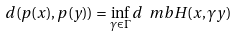Convert formula to latex. <formula><loc_0><loc_0><loc_500><loc_500>d ( p ( x ) , p ( y ) ) = \inf _ { \gamma \in \Gamma } d _ { \ } m b { H } ( x , \gamma y )</formula> 